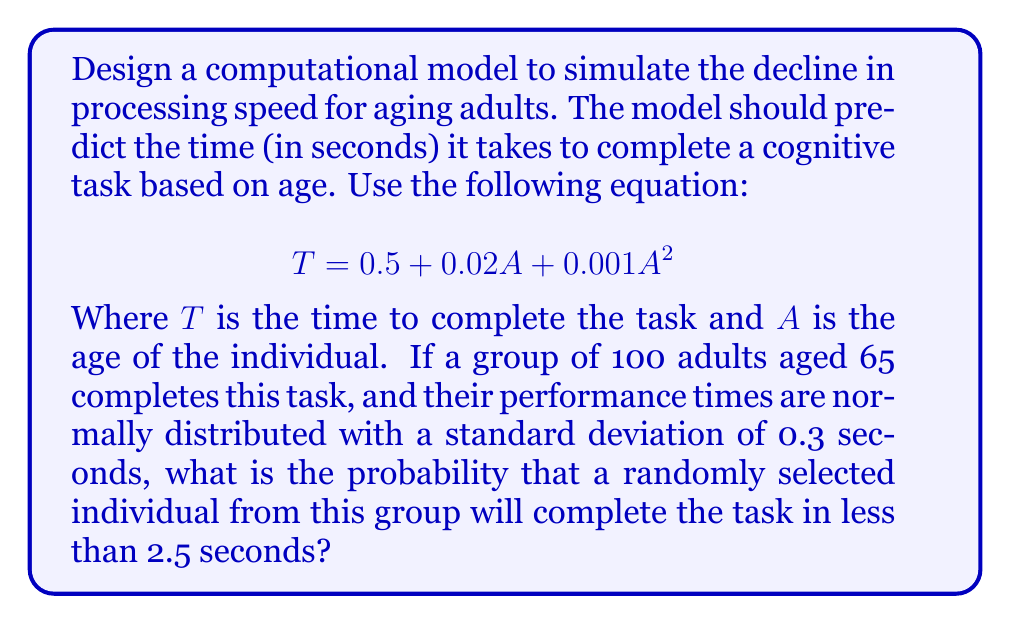Solve this math problem. To solve this problem, we'll follow these steps:

1. Calculate the mean time for 65-year-olds:
   $$T = 0.5 + 0.02A + 0.001A^2$$
   $$T = 0.5 + 0.02(65) + 0.001(65^2)$$
   $$T = 0.5 + 1.3 + 4.225 = 6.025\text{ seconds}$$

2. We're given that the times are normally distributed with a mean of 6.025 seconds and a standard deviation of 0.3 seconds.

3. To find the probability of completing the task in less than 2.5 seconds, we need to calculate the z-score:
   $$z = \frac{x - \mu}{\sigma} = \frac{2.5 - 6.025}{0.3} = -11.75$$

4. Using a standard normal distribution table or calculator, we need to find the probability of z < -11.75.

5. This probability is extremely small, effectively 0 when rounded to any reasonable number of decimal places.

This result indicates that it's virtually impossible for a 65-year-old in this model to complete the task in less than 2.5 seconds, given the predicted mean time and standard deviation.
Answer: The probability is effectively 0 (less than $1 \times 10^{-10}$). 